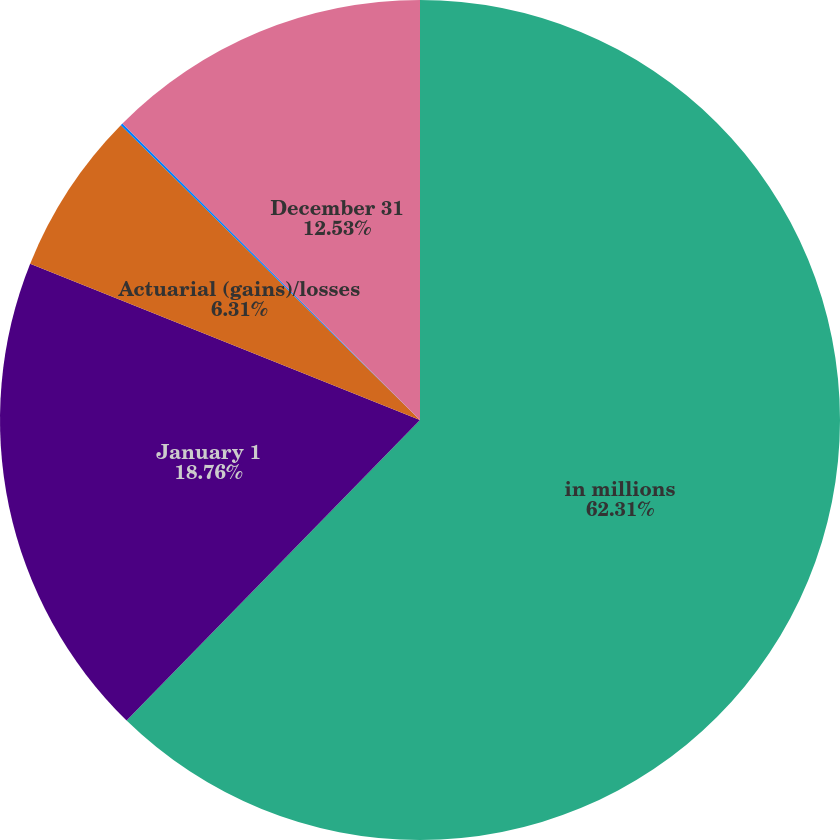<chart> <loc_0><loc_0><loc_500><loc_500><pie_chart><fcel>in millions<fcel>January 1<fcel>Actuarial (gains)/losses<fcel>Benefits paid<fcel>December 31<nl><fcel>62.31%<fcel>18.76%<fcel>6.31%<fcel>0.09%<fcel>12.53%<nl></chart> 